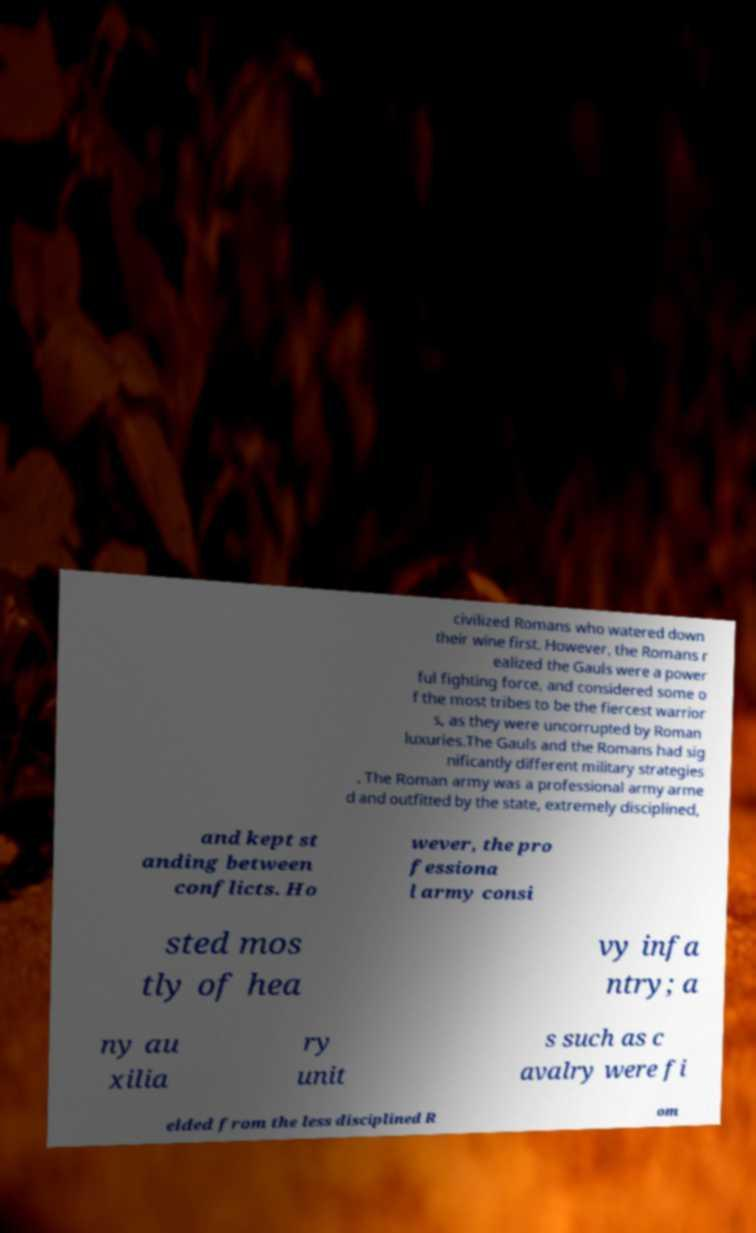I need the written content from this picture converted into text. Can you do that? civilized Romans who watered down their wine first. However, the Romans r ealized the Gauls were a power ful fighting force, and considered some o f the most tribes to be the fiercest warrior s, as they were uncorrupted by Roman luxuries.The Gauls and the Romans had sig nificantly different military strategies . The Roman army was a professional army arme d and outfitted by the state, extremely disciplined, and kept st anding between conflicts. Ho wever, the pro fessiona l army consi sted mos tly of hea vy infa ntry; a ny au xilia ry unit s such as c avalry were fi elded from the less disciplined R om 